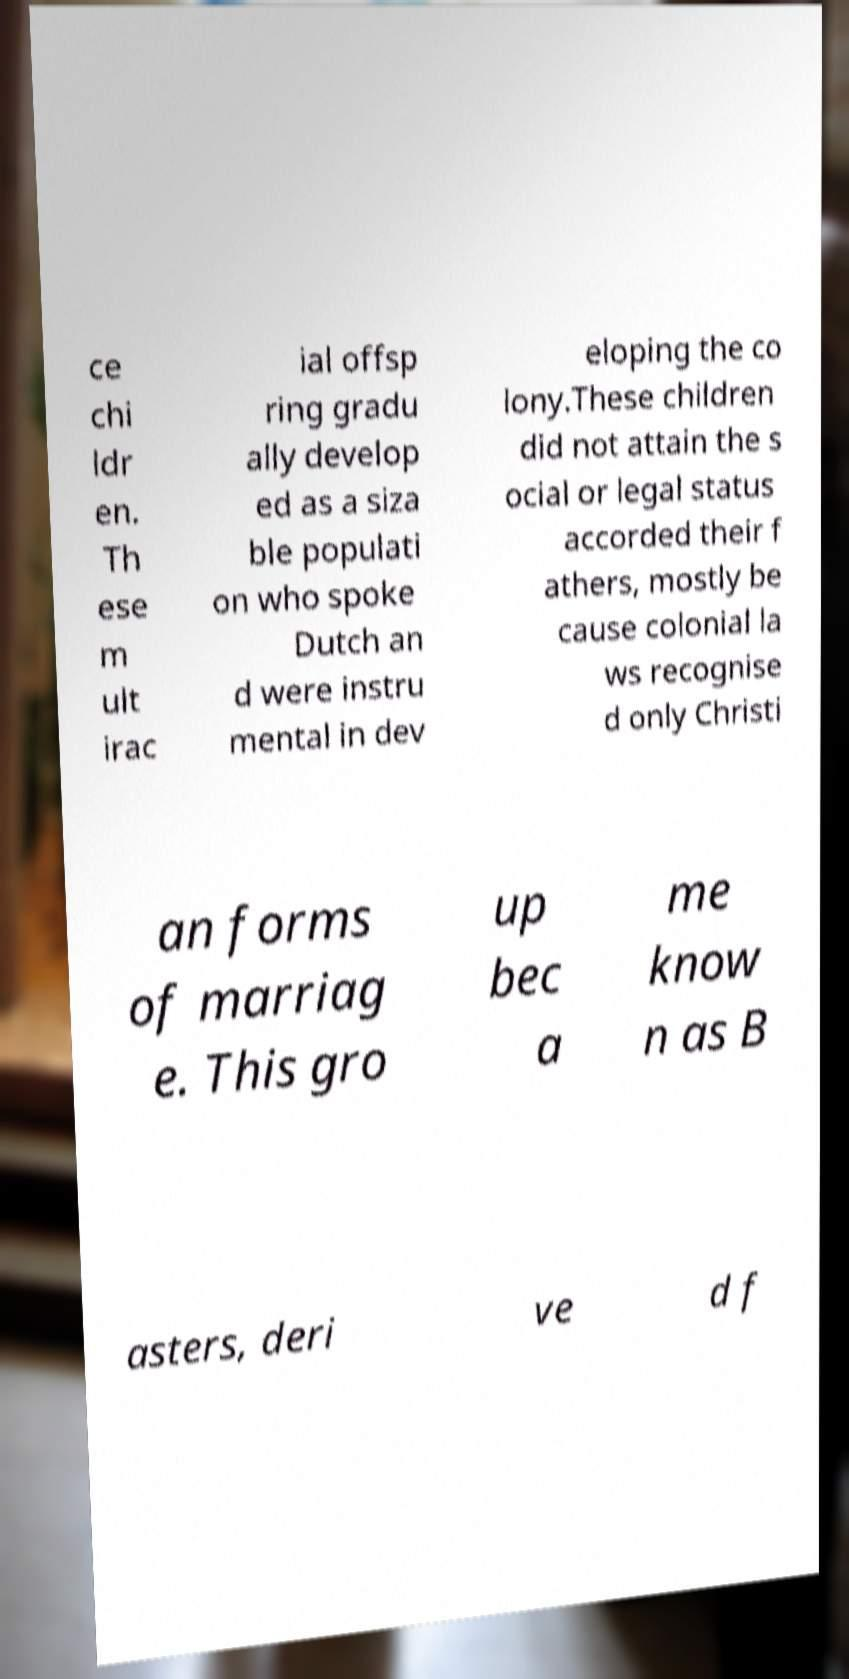Can you accurately transcribe the text from the provided image for me? ce chi ldr en. Th ese m ult irac ial offsp ring gradu ally develop ed as a siza ble populati on who spoke Dutch an d were instru mental in dev eloping the co lony.These children did not attain the s ocial or legal status accorded their f athers, mostly be cause colonial la ws recognise d only Christi an forms of marriag e. This gro up bec a me know n as B asters, deri ve d f 